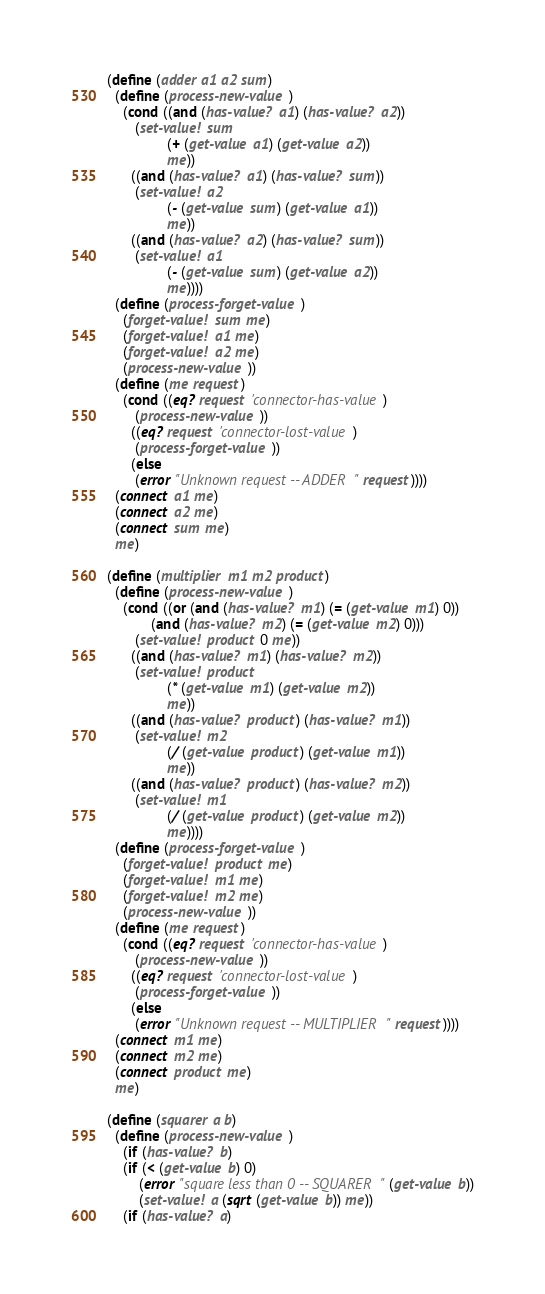<code> <loc_0><loc_0><loc_500><loc_500><_Scheme_>(define (adder a1 a2 sum)
  (define (process-new-value)
    (cond ((and (has-value? a1) (has-value? a2))
	   (set-value! sum
		       (+ (get-value a1) (get-value a2))
		       me))
	  ((and (has-value? a1) (has-value? sum))
	   (set-value! a2
		       (- (get-value sum) (get-value a1))
		       me))
	  ((and (has-value? a2) (has-value? sum))
	   (set-value! a1
		       (- (get-value sum) (get-value a2))
		       me))))
  (define (process-forget-value)
    (forget-value! sum me)
    (forget-value! a1 me)
    (forget-value! a2 me)
    (process-new-value))
  (define (me request)
    (cond ((eq? request 'connector-has-value)
	   (process-new-value))
	  ((eq? request 'connector-lost-value)
	   (process-forget-value))
	  (else
	   (error "Unknown request -- ADDER" request))))
  (connect a1 me)
  (connect a2 me)
  (connect sum me)
  me)

(define (multiplier m1 m2 product)
  (define (process-new-value)
    (cond ((or (and (has-value? m1) (= (get-value m1) 0))
	       (and (has-value? m2) (= (get-value m2) 0)))
	   (set-value! product 0 me))
	  ((and (has-value? m1) (has-value? m2))
	   (set-value! product
		       (* (get-value m1) (get-value m2))
		       me))
	  ((and (has-value? product) (has-value? m1))
	   (set-value! m2
		       (/ (get-value product) (get-value m1))
		       me))
	  ((and (has-value? product) (has-value? m2))
	   (set-value! m1
		       (/ (get-value product) (get-value m2))
		       me))))
  (define (process-forget-value)
    (forget-value! product me)
    (forget-value! m1 me)
    (forget-value! m2 me)
    (process-new-value))
  (define (me request)
    (cond ((eq? request 'connector-has-value)
	   (process-new-value))
	  ((eq? request 'connector-lost-value)
	   (process-forget-value))
	  (else
	   (error "Unknown request -- MULTIPLIER" request))))
  (connect m1 me)
  (connect m2 me)
  (connect product me)
  me)

(define (squarer a b)
  (define (process-new-value)
    (if (has-value? b)
	(if (< (get-value b) 0)
	    (error "square less than 0 -- SQUARER" (get-value b))
	    (set-value! a (sqrt (get-value b)) me))
	(if (has-value? a)</code> 